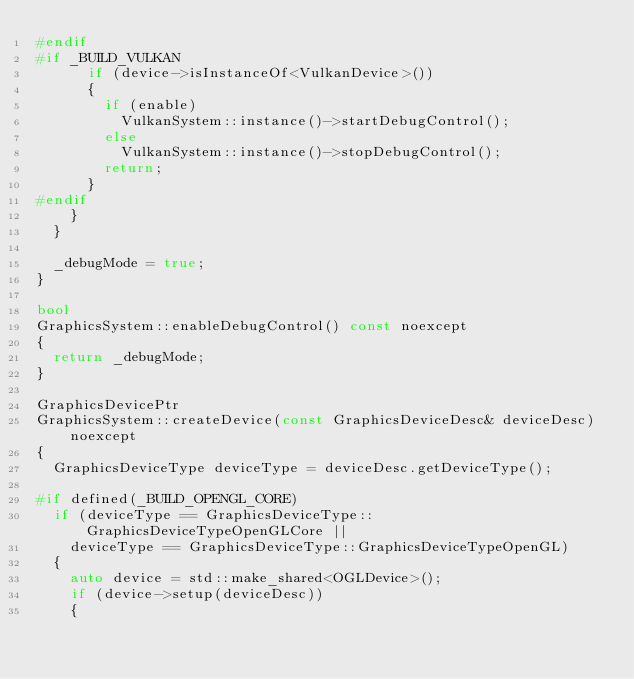<code> <loc_0><loc_0><loc_500><loc_500><_C++_>#endif
#if _BUILD_VULKAN
			if (device->isInstanceOf<VulkanDevice>())
			{
				if (enable)
					VulkanSystem::instance()->startDebugControl();
				else
					VulkanSystem::instance()->stopDebugControl();
				return;
			}
#endif
		}
	}

	_debugMode = true;
}

bool
GraphicsSystem::enableDebugControl() const noexcept
{
	return _debugMode;
}

GraphicsDevicePtr
GraphicsSystem::createDevice(const GraphicsDeviceDesc& deviceDesc) noexcept
{
	GraphicsDeviceType deviceType = deviceDesc.getDeviceType();

#if defined(_BUILD_OPENGL_CORE)
	if (deviceType == GraphicsDeviceType::GraphicsDeviceTypeOpenGLCore ||
		deviceType == GraphicsDeviceType::GraphicsDeviceTypeOpenGL)
	{
		auto device = std::make_shared<OGLDevice>();
		if (device->setup(deviceDesc))
		{</code> 